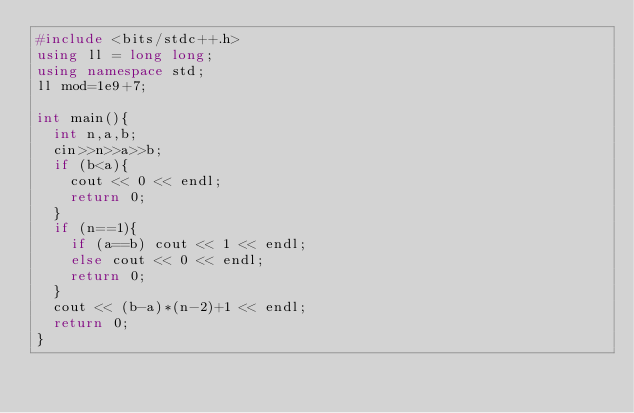Convert code to text. <code><loc_0><loc_0><loc_500><loc_500><_C++_>#include <bits/stdc++.h>
using ll = long long;
using namespace std;
ll mod=1e9+7;

int main(){
  int n,a,b;
  cin>>n>>a>>b;
  if (b<a){
    cout << 0 << endl;
    return 0;
  }
  if (n==1){
    if (a==b) cout << 1 << endl;
    else cout << 0 << endl;
    return 0;
  }
  cout << (b-a)*(n-2)+1 << endl;
  return 0;
}

</code> 